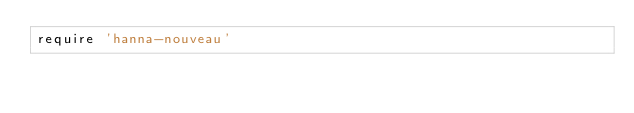Convert code to text. <code><loc_0><loc_0><loc_500><loc_500><_Ruby_>require 'hanna-nouveau'
</code> 